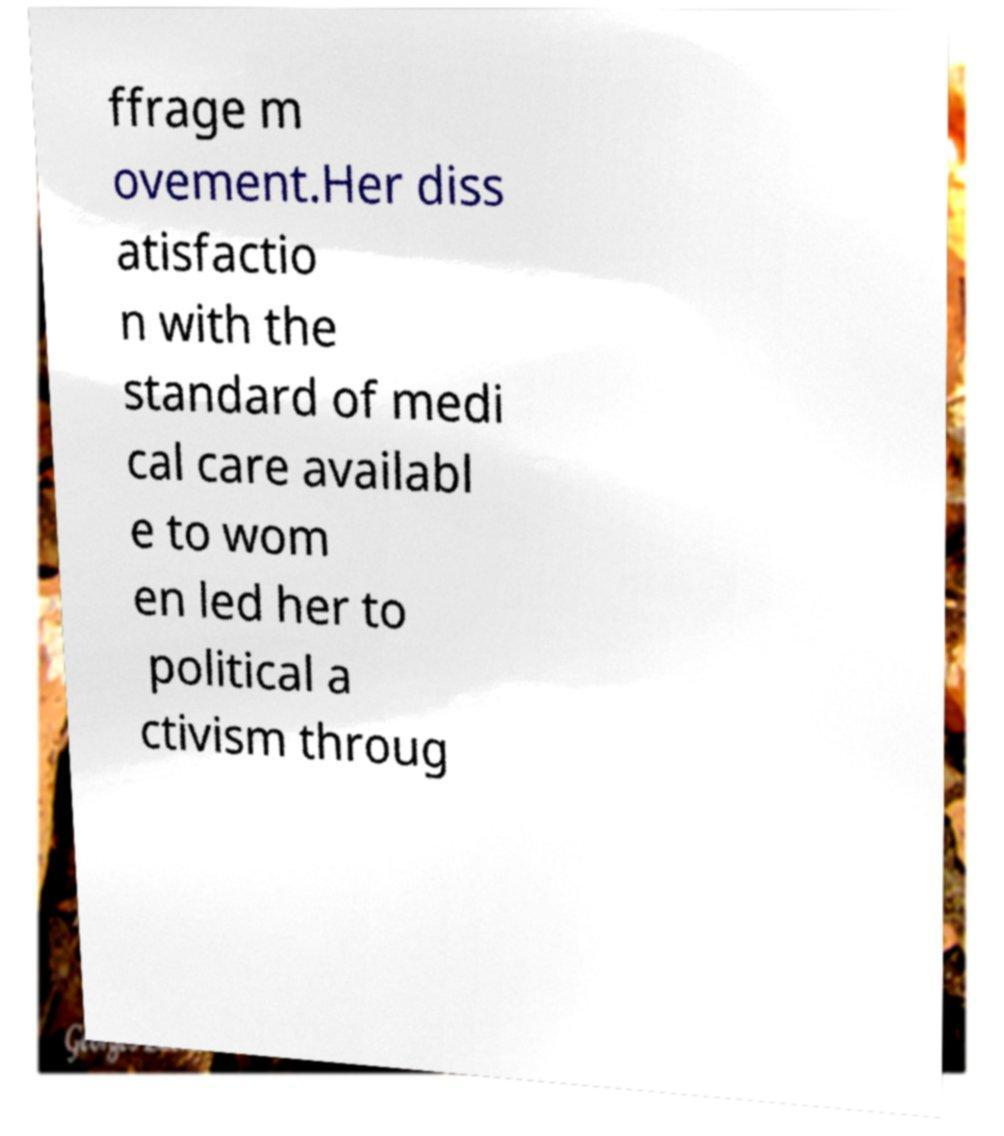There's text embedded in this image that I need extracted. Can you transcribe it verbatim? ffrage m ovement.Her diss atisfactio n with the standard of medi cal care availabl e to wom en led her to political a ctivism throug 